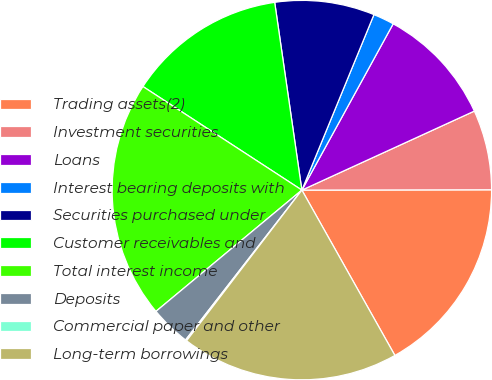Convert chart. <chart><loc_0><loc_0><loc_500><loc_500><pie_chart><fcel>Trading assets(2)<fcel>Investment securities<fcel>Loans<fcel>Interest bearing deposits with<fcel>Securities purchased under<fcel>Customer receivables and<fcel>Total interest income<fcel>Deposits<fcel>Commercial paper and other<fcel>Long-term borrowings<nl><fcel>16.87%<fcel>6.81%<fcel>10.17%<fcel>1.79%<fcel>8.49%<fcel>13.52%<fcel>20.23%<fcel>3.46%<fcel>0.11%<fcel>18.55%<nl></chart> 